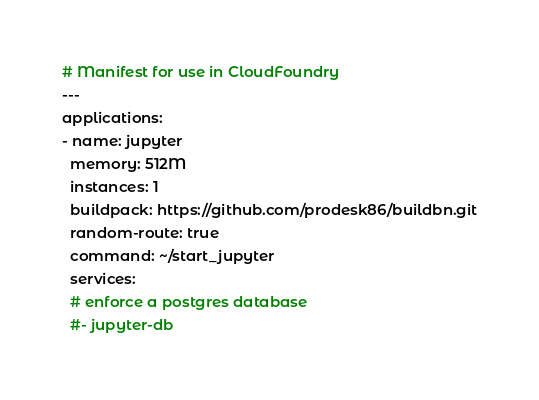<code> <loc_0><loc_0><loc_500><loc_500><_YAML_># Manifest for use in CloudFoundry
---
applications:
- name: jupyter
  memory: 512M
  instances: 1
  buildpack: https://github.com/prodesk86/buildbn.git
  random-route: true
  command: ~/start_jupyter
  services:
  # enforce a postgres database
  #- jupyter-db
</code> 